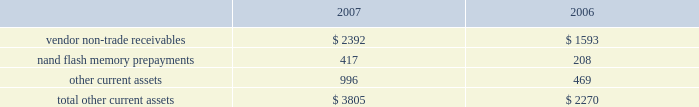Notes to consolidated financial statements ( continued ) note 2 2014financial instruments ( continued ) typically , the company hedges portions of its forecasted foreign currency exposure associated with revenue and inventory purchases over a time horizon of up to 6 months .
Derivative instruments designated as cash flow hedges must be de-designated as hedges when it is probable the forecasted hedged transaction will not occur in the initially identified time period or within a subsequent 2 month time period .
Deferred gains and losses in other comprehensive income associated with such derivative instruments are immediately reclassified into earnings in other income and expense .
Any subsequent changes in fair value of such derivative instruments are also reflected in current earnings unless they are re-designated as hedges of other transactions .
The company recognized net gains of approximately $ 672000 and $ 421000 in 2007 and 2006 , respectively , and a net loss of $ 1.6 million in 2005 in other income and expense related to the loss of hedge designation on discontinued cash flow hedges due to changes in the company 2019s forecast of future net sales and cost of sales and due to prevailing market conditions .
As of september 29 , 2007 , the company had a net deferred gain associated with cash flow hedges of approximately $ 468000 , net of taxes , substantially all of which is expected to be reclassified to earnings by the end of the second quarter of fiscal 2008 .
The net gain or loss on the effective portion of a derivative instrument designated as a net investment hedge is included in the cumulative translation adjustment account of accumulated other comprehensive income within shareholders 2019 equity .
For the years ended september 29 , 2007 and september 30 , 2006 , the company had a net loss of $ 2.6 million and a net gain of $ 7.4 million , respectively , included in the cumulative translation adjustment .
The company may also enter into foreign currency forward and option contracts to offset the foreign exchange gains and losses generated by the re-measurement of certain assets and liabilities recorded in non-functional currencies .
Changes in the fair value of these derivatives are recognized in current earnings in other income and expense as offsets to the changes in the fair value of the related assets or liabilities .
Due to currency market movements , changes in option time value can lead to increased volatility in other income and expense .
Note 3 2014consolidated financial statement details ( in millions ) other current assets .

What percentage of total other current assets in 2007 was comprised of nand flash memory prepayments? 
Computations: (417 / 3805)
Answer: 0.10959. 